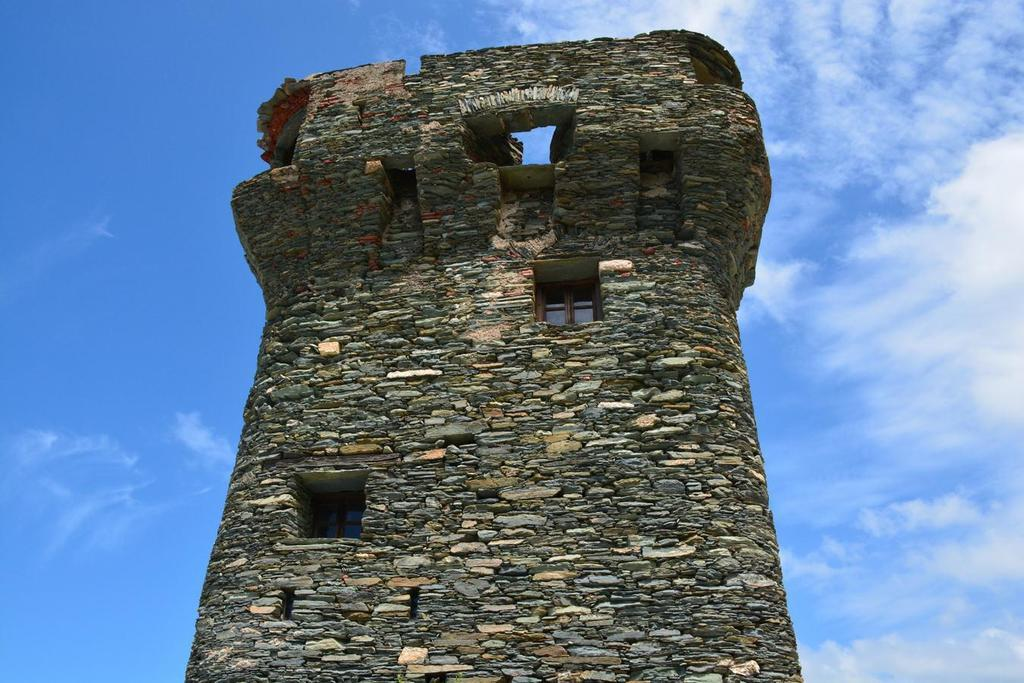What type of building is in the image? There is a stone building in the image. Are there any openings in the building? Yes, there is a window in the building. What is the condition of the sky in the image? The sky is cloudy in the image. What type of butter can be seen in the image? There is no butter present in the image. 